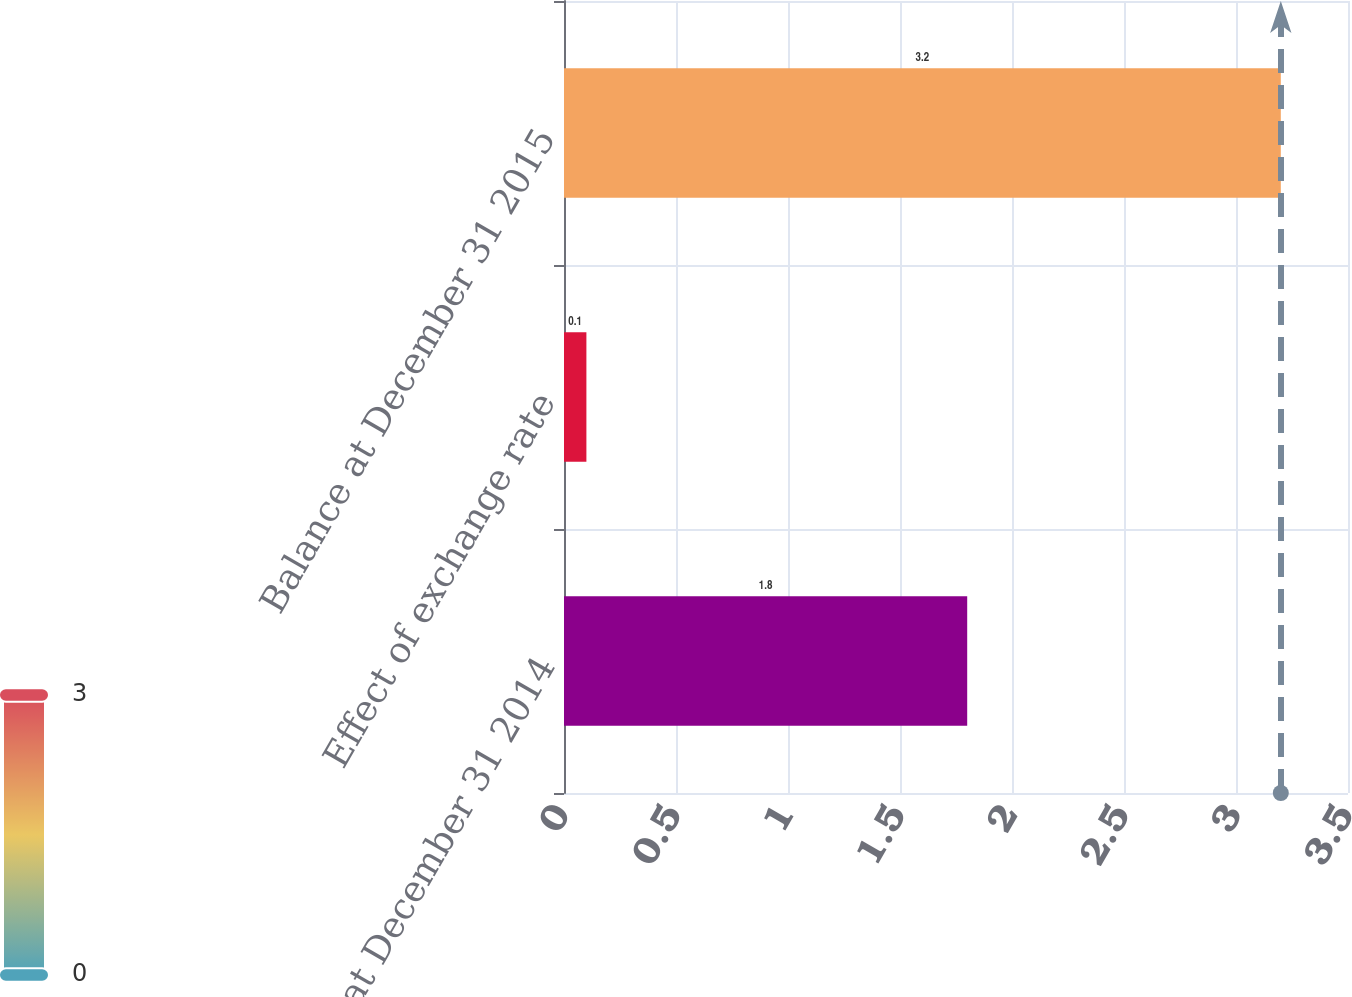<chart> <loc_0><loc_0><loc_500><loc_500><bar_chart><fcel>Balance at December 31 2014<fcel>Effect of exchange rate<fcel>Balance at December 31 2015<nl><fcel>1.8<fcel>0.1<fcel>3.2<nl></chart> 